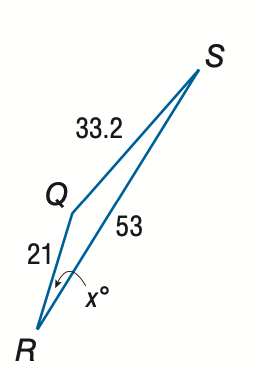Question: Find x. Round the angle measure to the nearest degree.
Choices:
A. 12
B. 15
C. 18
D. 21
Answer with the letter. Answer: B 